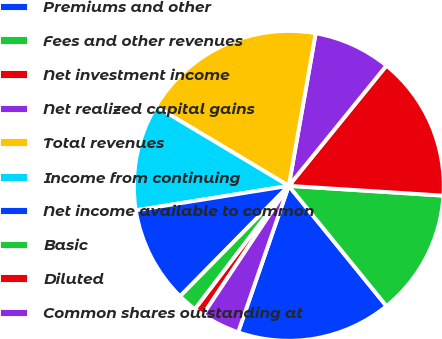Convert chart to OTSL. <chart><loc_0><loc_0><loc_500><loc_500><pie_chart><fcel>Premiums and other<fcel>Fees and other revenues<fcel>Net investment income<fcel>Net realized capital gains<fcel>Total revenues<fcel>Income from continuing<fcel>Net income available to common<fcel>Basic<fcel>Diluted<fcel>Common shares outstanding at<nl><fcel>16.16%<fcel>13.13%<fcel>15.15%<fcel>8.08%<fcel>19.19%<fcel>11.11%<fcel>10.1%<fcel>2.02%<fcel>1.01%<fcel>4.04%<nl></chart> 